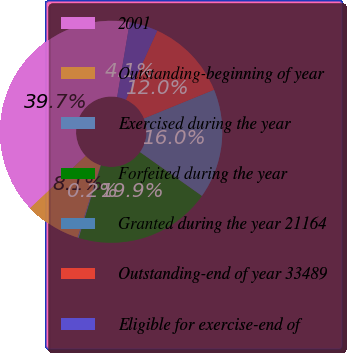Convert chart to OTSL. <chart><loc_0><loc_0><loc_500><loc_500><pie_chart><fcel>2001<fcel>Outstanding-beginning of year<fcel>Exercised during the year<fcel>Forfeited during the year<fcel>Granted during the year 21164<fcel>Outstanding-end of year 33489<fcel>Eligible for exercise-end of<nl><fcel>39.68%<fcel>8.08%<fcel>0.18%<fcel>19.93%<fcel>15.98%<fcel>12.03%<fcel>4.13%<nl></chart> 